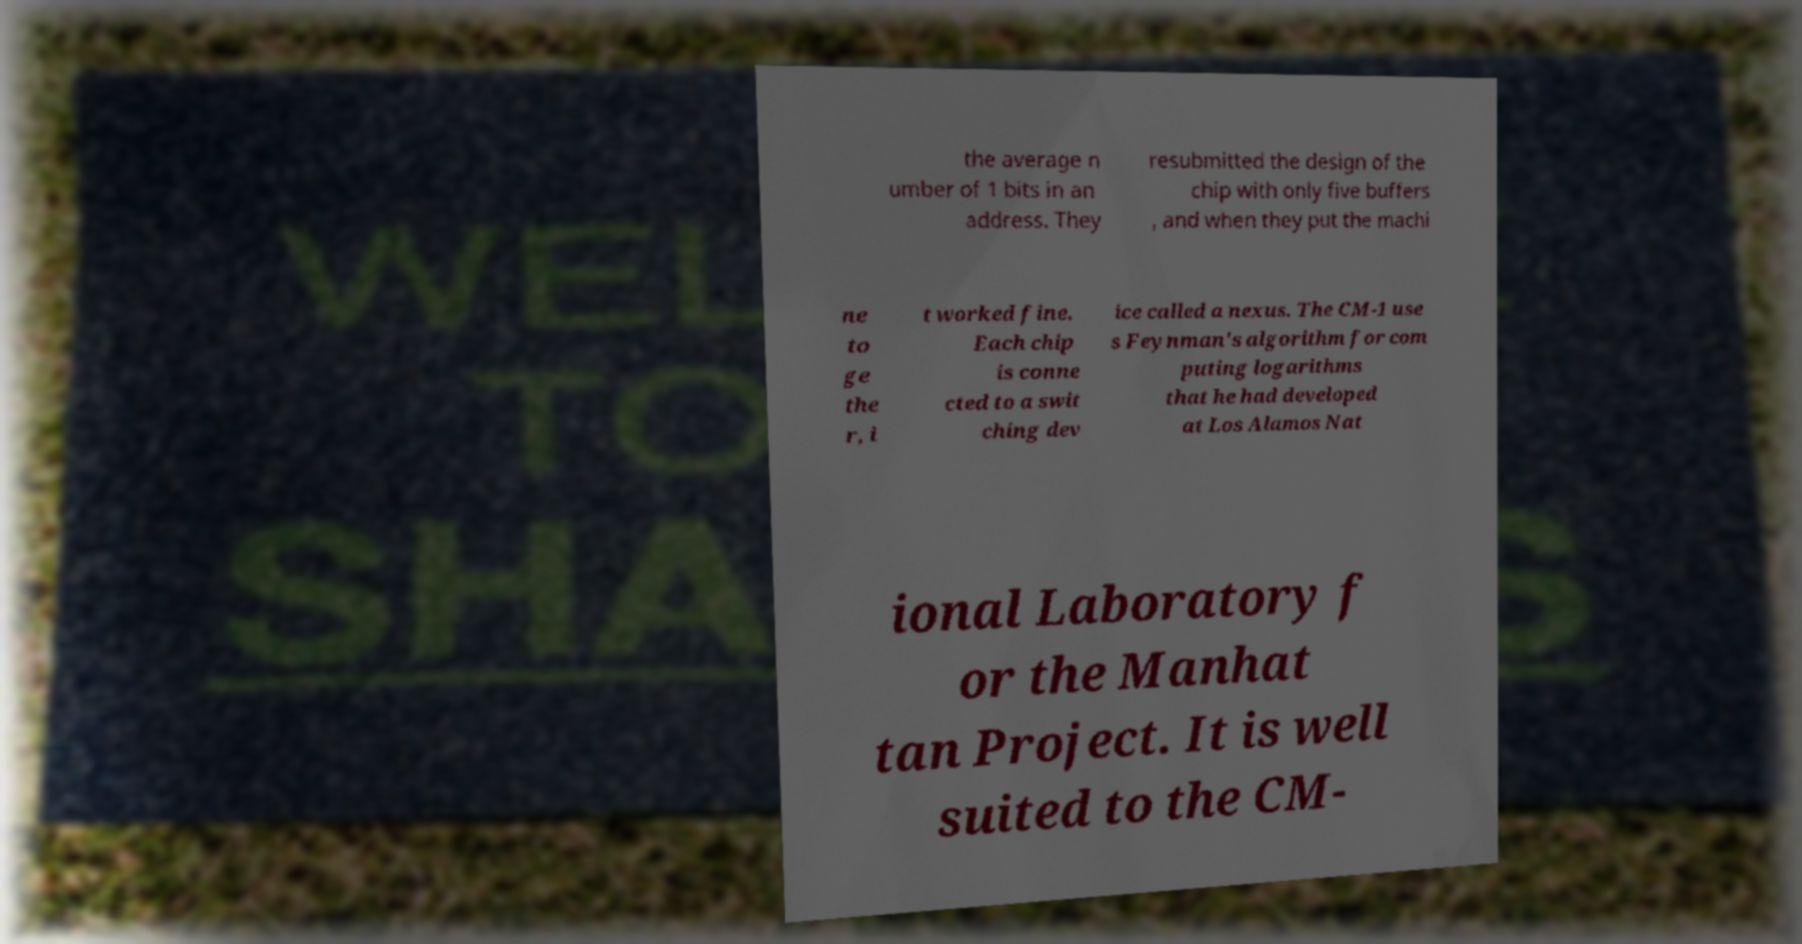Could you extract and type out the text from this image? the average n umber of 1 bits in an address. They resubmitted the design of the chip with only five buffers , and when they put the machi ne to ge the r, i t worked fine. Each chip is conne cted to a swit ching dev ice called a nexus. The CM-1 use s Feynman's algorithm for com puting logarithms that he had developed at Los Alamos Nat ional Laboratory f or the Manhat tan Project. It is well suited to the CM- 